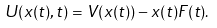<formula> <loc_0><loc_0><loc_500><loc_500>U ( x ( t ) , t ) = V ( x ( t ) ) - x ( t ) F ( t ) .</formula> 